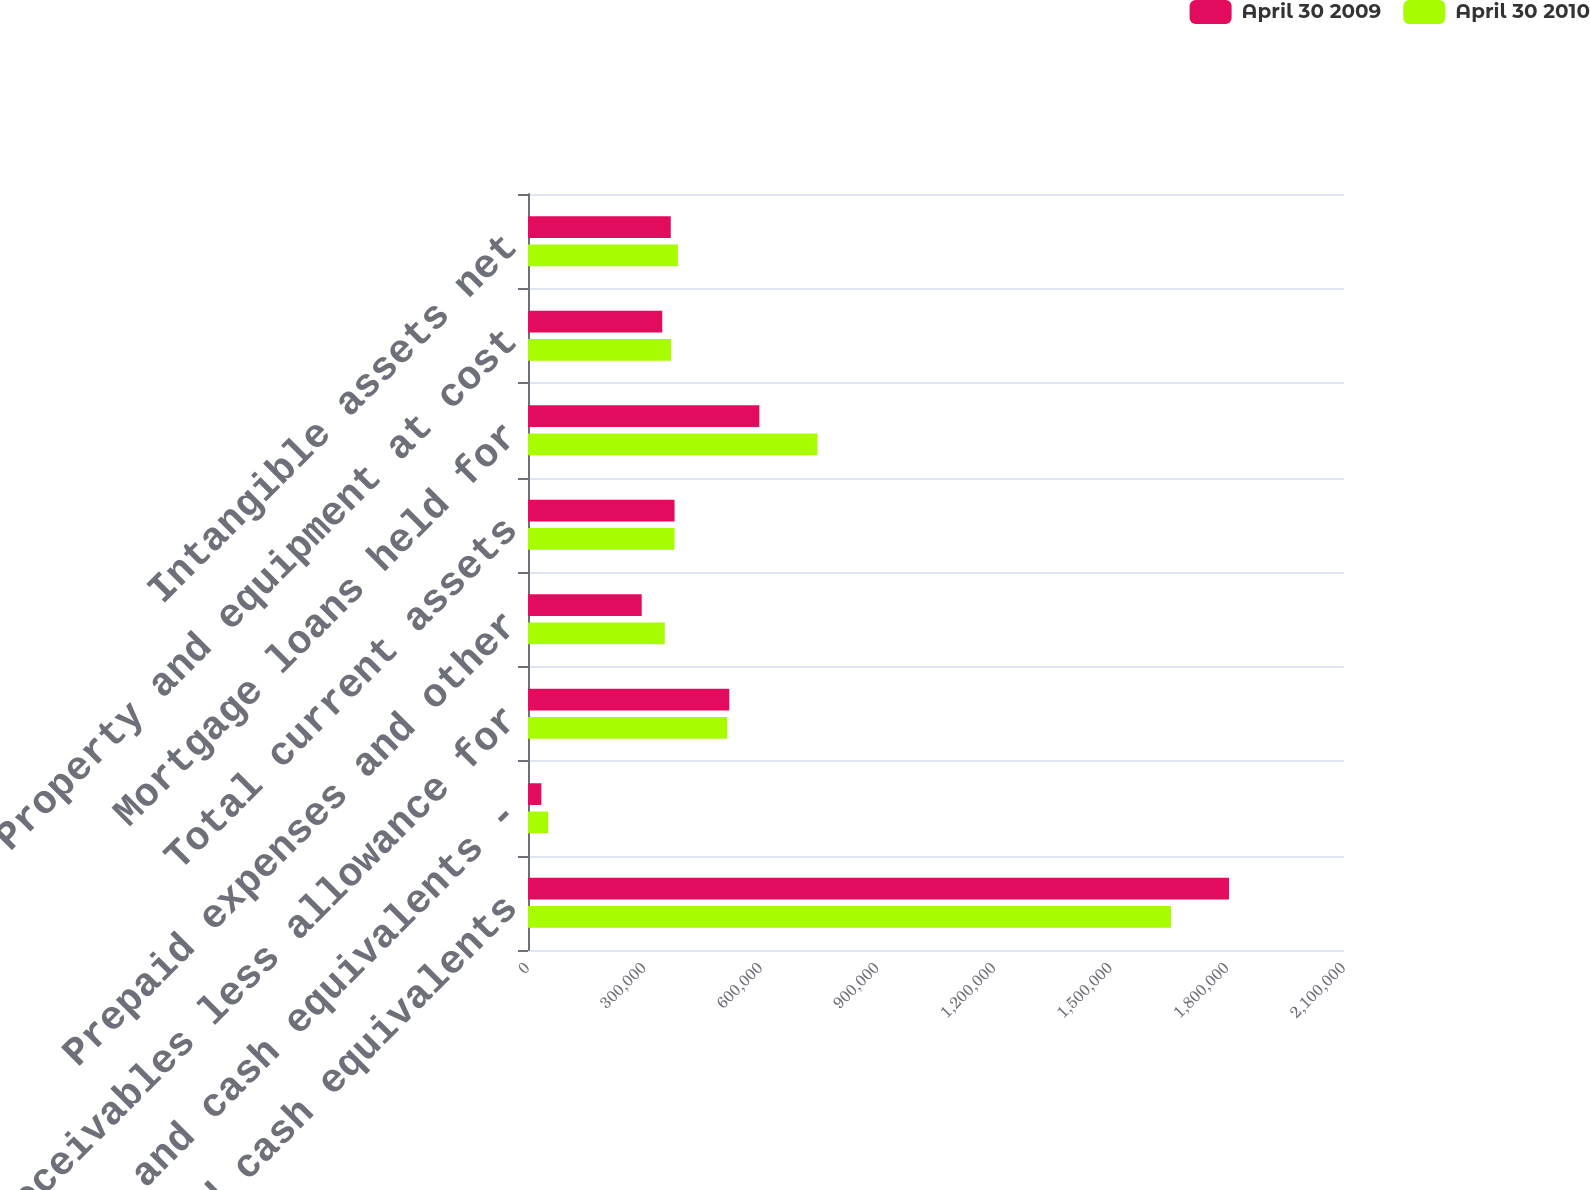<chart> <loc_0><loc_0><loc_500><loc_500><stacked_bar_chart><ecel><fcel>Cash and cash equivalents<fcel>Cash and cash equivalents -<fcel>Receivables less allowance for<fcel>Prepaid expenses and other<fcel>Total current assets<fcel>Mortgage loans held for<fcel>Property and equipment at cost<fcel>Intangible assets net<nl><fcel>April 30 2009<fcel>1.80404e+06<fcel>34350<fcel>517986<fcel>292655<fcel>377144<fcel>595405<fcel>345470<fcel>367432<nl><fcel>April 30 2010<fcel>1.65466e+06<fcel>51656<fcel>512814<fcel>351947<fcel>377144<fcel>744899<fcel>368289<fcel>385998<nl></chart> 